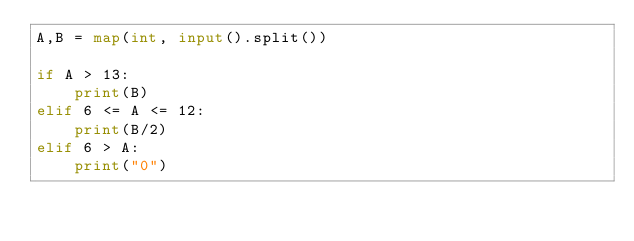Convert code to text. <code><loc_0><loc_0><loc_500><loc_500><_Python_>A,B = map(int, input().split())

if A > 13:
    print(B)
elif 6 <= A <= 12:
    print(B/2)
elif 6 > A:
    print("0")

</code> 